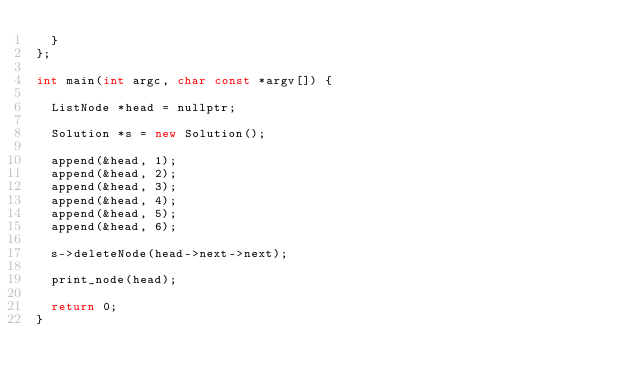<code> <loc_0><loc_0><loc_500><loc_500><_C++_>  }
};

int main(int argc, char const *argv[]) {

  ListNode *head = nullptr;

  Solution *s = new Solution();

  append(&head, 1);
  append(&head, 2);
  append(&head, 3);
  append(&head, 4);
  append(&head, 5);
  append(&head, 6);

  s->deleteNode(head->next->next);

  print_node(head);

  return 0;
}</code> 